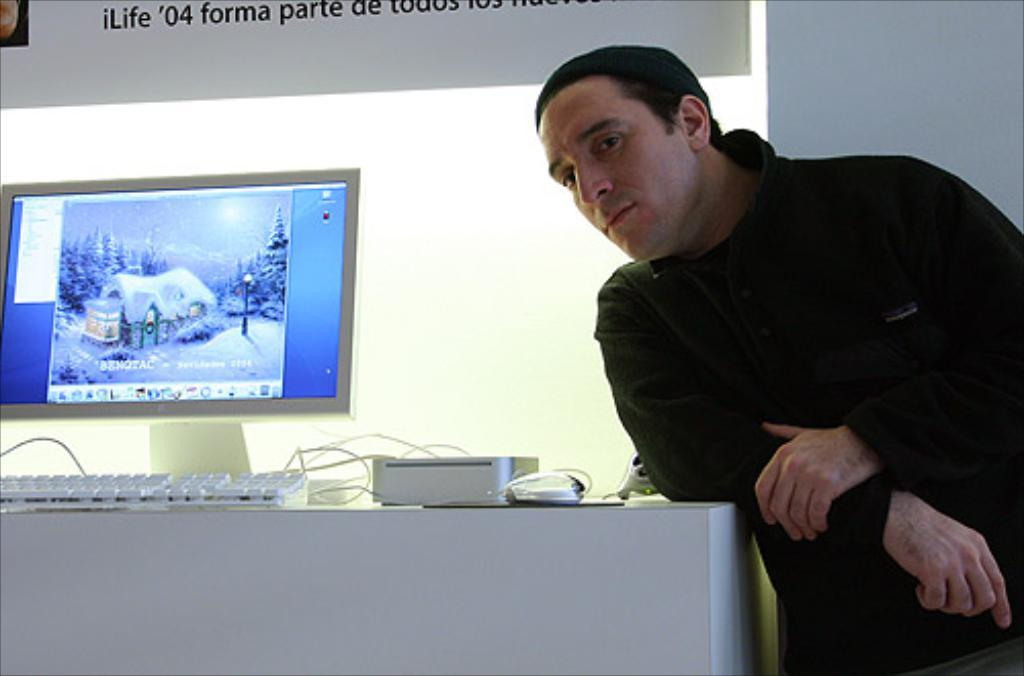What type of table is in the image? There is a white table in the image. What is placed on the table? A keyboard and devices are present on the table. What is the purpose of the monitor on the table? The monitor is likely used for displaying information or visuals. Can you describe the person standing beside the table? There is a person standing beside the table, but their appearance or actions are not described in the facts. What type of clam is being discussed by the person standing beside the table? There is no mention of a clam or any discussion in the image. 